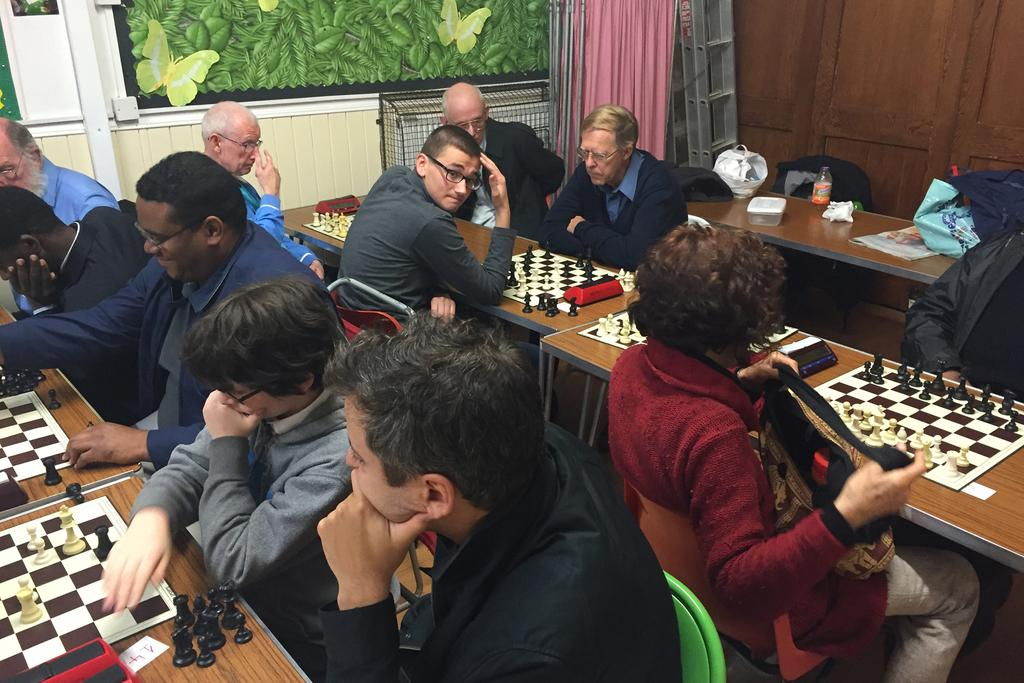How many people are in the image? There is a group of people in the image. What are the people doing in the image? The people are playing chess. What is the position of the people in the image? The people are seated. What object is present in the image that the people might be using to play chess? There is a table in the image. Can you see any goldfish swimming in the image? There are no goldfish present in the image. How many chickens are there in the image? There are no chickens present in the image. 